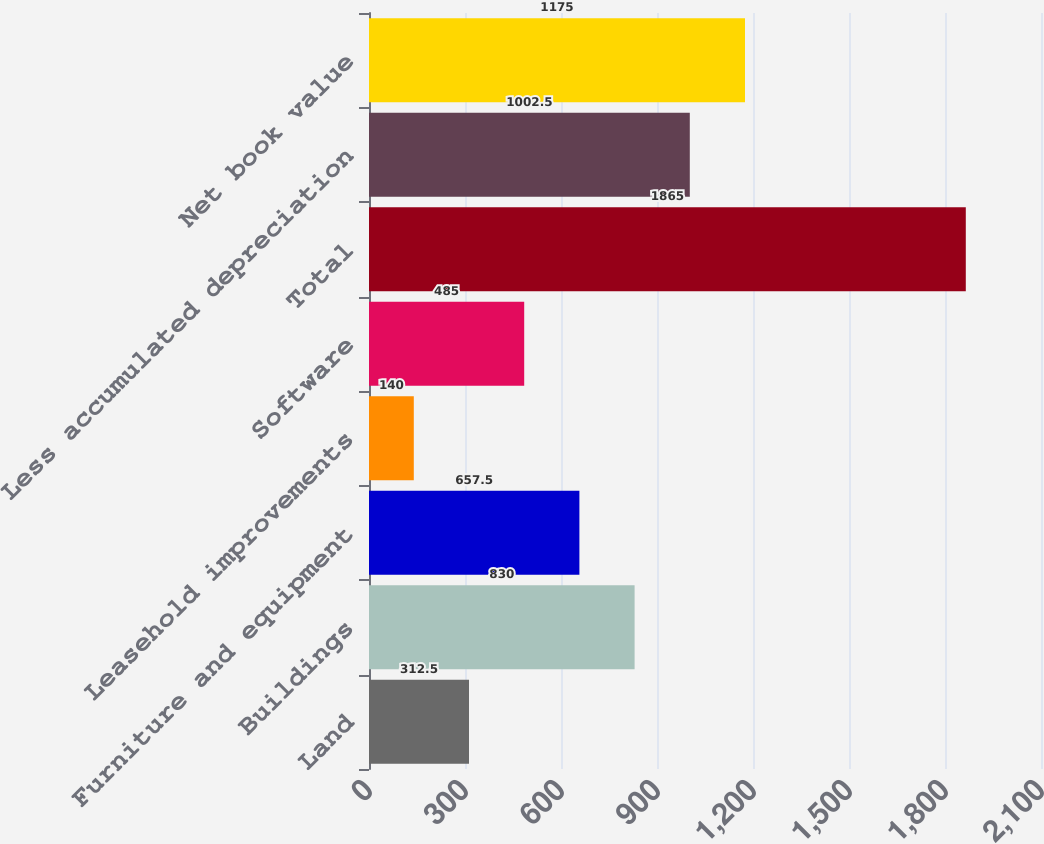Convert chart to OTSL. <chart><loc_0><loc_0><loc_500><loc_500><bar_chart><fcel>Land<fcel>Buildings<fcel>Furniture and equipment<fcel>Leasehold improvements<fcel>Software<fcel>Total<fcel>Less accumulated depreciation<fcel>Net book value<nl><fcel>312.5<fcel>830<fcel>657.5<fcel>140<fcel>485<fcel>1865<fcel>1002.5<fcel>1175<nl></chart> 